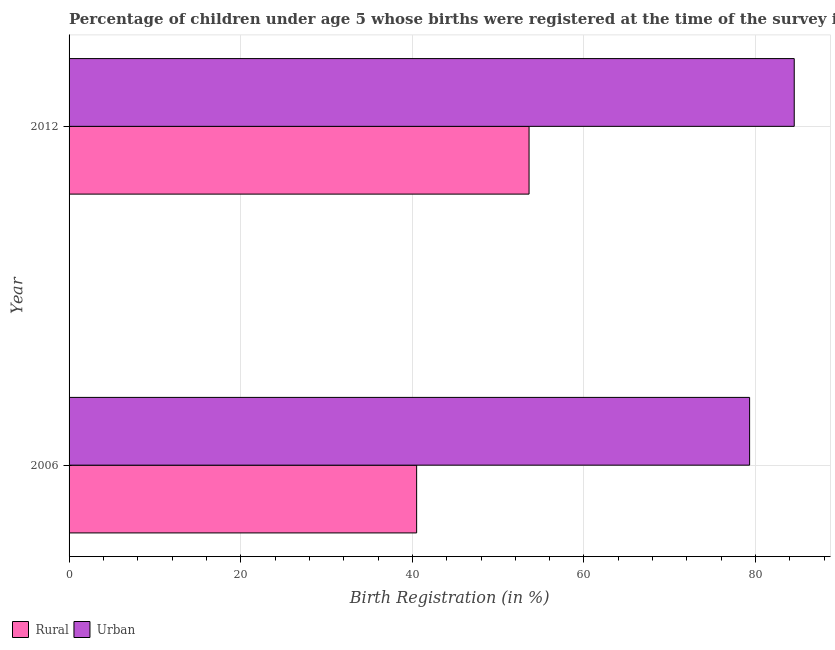How many different coloured bars are there?
Make the answer very short. 2. Are the number of bars on each tick of the Y-axis equal?
Ensure brevity in your answer.  Yes. What is the label of the 1st group of bars from the top?
Provide a short and direct response. 2012. In how many cases, is the number of bars for a given year not equal to the number of legend labels?
Your answer should be very brief. 0. What is the urban birth registration in 2012?
Offer a terse response. 84.5. Across all years, what is the maximum rural birth registration?
Ensure brevity in your answer.  53.6. Across all years, what is the minimum rural birth registration?
Provide a succinct answer. 40.5. In which year was the rural birth registration maximum?
Provide a succinct answer. 2012. In which year was the rural birth registration minimum?
Your response must be concise. 2006. What is the total rural birth registration in the graph?
Provide a short and direct response. 94.1. What is the difference between the urban birth registration in 2006 and the rural birth registration in 2012?
Your response must be concise. 25.7. What is the average rural birth registration per year?
Make the answer very short. 47.05. In the year 2006, what is the difference between the rural birth registration and urban birth registration?
Ensure brevity in your answer.  -38.8. In how many years, is the rural birth registration greater than 64 %?
Keep it short and to the point. 0. What is the ratio of the rural birth registration in 2006 to that in 2012?
Ensure brevity in your answer.  0.76. Is the difference between the urban birth registration in 2006 and 2012 greater than the difference between the rural birth registration in 2006 and 2012?
Keep it short and to the point. Yes. In how many years, is the rural birth registration greater than the average rural birth registration taken over all years?
Make the answer very short. 1. What does the 1st bar from the top in 2006 represents?
Make the answer very short. Urban. What does the 2nd bar from the bottom in 2012 represents?
Give a very brief answer. Urban. What is the difference between two consecutive major ticks on the X-axis?
Your answer should be very brief. 20. Are the values on the major ticks of X-axis written in scientific E-notation?
Give a very brief answer. No. Does the graph contain any zero values?
Provide a succinct answer. No. Does the graph contain grids?
Make the answer very short. Yes. How many legend labels are there?
Give a very brief answer. 2. How are the legend labels stacked?
Ensure brevity in your answer.  Horizontal. What is the title of the graph?
Keep it short and to the point. Percentage of children under age 5 whose births were registered at the time of the survey in Cote d'Ivoire. Does "Nitrous oxide emissions" appear as one of the legend labels in the graph?
Give a very brief answer. No. What is the label or title of the X-axis?
Offer a terse response. Birth Registration (in %). What is the Birth Registration (in %) of Rural in 2006?
Your answer should be very brief. 40.5. What is the Birth Registration (in %) in Urban in 2006?
Offer a very short reply. 79.3. What is the Birth Registration (in %) in Rural in 2012?
Keep it short and to the point. 53.6. What is the Birth Registration (in %) in Urban in 2012?
Keep it short and to the point. 84.5. Across all years, what is the maximum Birth Registration (in %) of Rural?
Your response must be concise. 53.6. Across all years, what is the maximum Birth Registration (in %) in Urban?
Your response must be concise. 84.5. Across all years, what is the minimum Birth Registration (in %) in Rural?
Provide a succinct answer. 40.5. Across all years, what is the minimum Birth Registration (in %) of Urban?
Make the answer very short. 79.3. What is the total Birth Registration (in %) of Rural in the graph?
Make the answer very short. 94.1. What is the total Birth Registration (in %) of Urban in the graph?
Make the answer very short. 163.8. What is the difference between the Birth Registration (in %) in Rural in 2006 and the Birth Registration (in %) in Urban in 2012?
Your response must be concise. -44. What is the average Birth Registration (in %) in Rural per year?
Ensure brevity in your answer.  47.05. What is the average Birth Registration (in %) of Urban per year?
Provide a short and direct response. 81.9. In the year 2006, what is the difference between the Birth Registration (in %) in Rural and Birth Registration (in %) in Urban?
Provide a short and direct response. -38.8. In the year 2012, what is the difference between the Birth Registration (in %) of Rural and Birth Registration (in %) of Urban?
Keep it short and to the point. -30.9. What is the ratio of the Birth Registration (in %) of Rural in 2006 to that in 2012?
Your answer should be very brief. 0.76. What is the ratio of the Birth Registration (in %) in Urban in 2006 to that in 2012?
Keep it short and to the point. 0.94. 